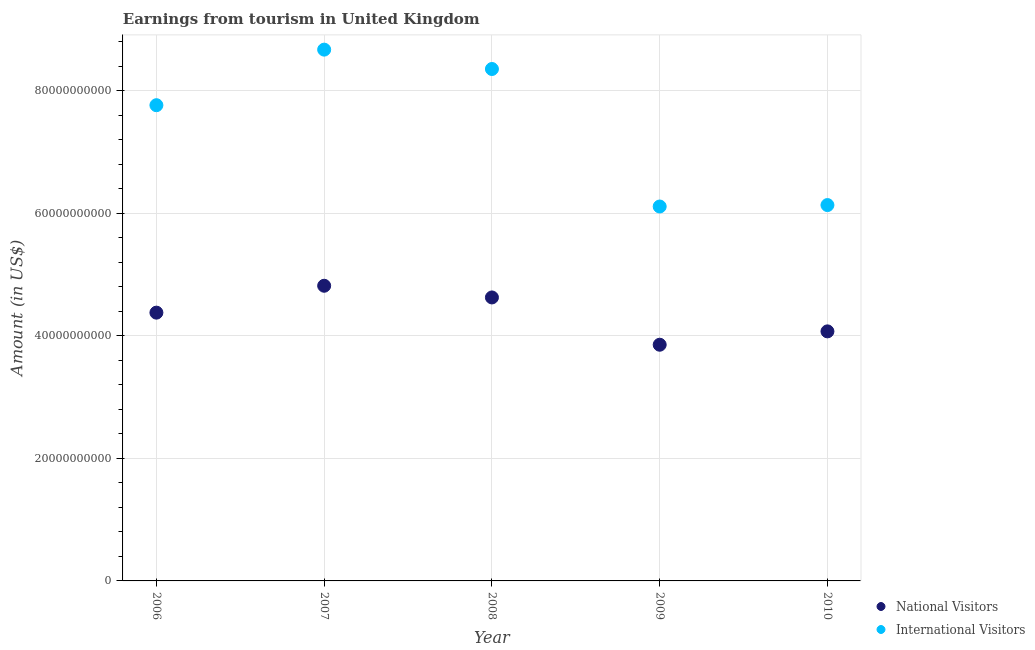How many different coloured dotlines are there?
Your response must be concise. 2. What is the amount earned from national visitors in 2008?
Provide a short and direct response. 4.63e+1. Across all years, what is the maximum amount earned from national visitors?
Give a very brief answer. 4.82e+1. Across all years, what is the minimum amount earned from national visitors?
Ensure brevity in your answer.  3.86e+1. What is the total amount earned from international visitors in the graph?
Ensure brevity in your answer.  3.71e+11. What is the difference between the amount earned from international visitors in 2006 and that in 2008?
Offer a very short reply. -5.91e+09. What is the difference between the amount earned from international visitors in 2006 and the amount earned from national visitors in 2008?
Your answer should be very brief. 3.14e+1. What is the average amount earned from national visitors per year?
Make the answer very short. 4.35e+1. In the year 2009, what is the difference between the amount earned from national visitors and amount earned from international visitors?
Make the answer very short. -2.26e+1. What is the ratio of the amount earned from national visitors in 2009 to that in 2010?
Your answer should be very brief. 0.95. Is the amount earned from national visitors in 2006 less than that in 2007?
Provide a short and direct response. Yes. Is the difference between the amount earned from national visitors in 2008 and 2010 greater than the difference between the amount earned from international visitors in 2008 and 2010?
Make the answer very short. No. What is the difference between the highest and the second highest amount earned from international visitors?
Give a very brief answer. 3.16e+09. What is the difference between the highest and the lowest amount earned from international visitors?
Provide a succinct answer. 2.56e+1. In how many years, is the amount earned from international visitors greater than the average amount earned from international visitors taken over all years?
Give a very brief answer. 3. Is the sum of the amount earned from international visitors in 2007 and 2009 greater than the maximum amount earned from national visitors across all years?
Ensure brevity in your answer.  Yes. How many dotlines are there?
Provide a succinct answer. 2. Are the values on the major ticks of Y-axis written in scientific E-notation?
Your answer should be compact. No. Does the graph contain any zero values?
Your answer should be compact. No. How many legend labels are there?
Provide a short and direct response. 2. What is the title of the graph?
Offer a very short reply. Earnings from tourism in United Kingdom. Does "Public funds" appear as one of the legend labels in the graph?
Provide a succinct answer. No. What is the label or title of the Y-axis?
Your response must be concise. Amount (in US$). What is the Amount (in US$) in National Visitors in 2006?
Give a very brief answer. 4.38e+1. What is the Amount (in US$) of International Visitors in 2006?
Offer a very short reply. 7.77e+1. What is the Amount (in US$) in National Visitors in 2007?
Your answer should be very brief. 4.82e+1. What is the Amount (in US$) in International Visitors in 2007?
Provide a short and direct response. 8.67e+1. What is the Amount (in US$) in National Visitors in 2008?
Provide a succinct answer. 4.63e+1. What is the Amount (in US$) of International Visitors in 2008?
Give a very brief answer. 8.36e+1. What is the Amount (in US$) in National Visitors in 2009?
Your response must be concise. 3.86e+1. What is the Amount (in US$) of International Visitors in 2009?
Make the answer very short. 6.11e+1. What is the Amount (in US$) of National Visitors in 2010?
Keep it short and to the point. 4.07e+1. What is the Amount (in US$) in International Visitors in 2010?
Offer a very short reply. 6.14e+1. Across all years, what is the maximum Amount (in US$) in National Visitors?
Make the answer very short. 4.82e+1. Across all years, what is the maximum Amount (in US$) in International Visitors?
Ensure brevity in your answer.  8.67e+1. Across all years, what is the minimum Amount (in US$) of National Visitors?
Provide a succinct answer. 3.86e+1. Across all years, what is the minimum Amount (in US$) in International Visitors?
Your answer should be compact. 6.11e+1. What is the total Amount (in US$) in National Visitors in the graph?
Provide a short and direct response. 2.18e+11. What is the total Amount (in US$) of International Visitors in the graph?
Keep it short and to the point. 3.71e+11. What is the difference between the Amount (in US$) of National Visitors in 2006 and that in 2007?
Keep it short and to the point. -4.39e+09. What is the difference between the Amount (in US$) in International Visitors in 2006 and that in 2007?
Your answer should be compact. -9.07e+09. What is the difference between the Amount (in US$) of National Visitors in 2006 and that in 2008?
Offer a terse response. -2.48e+09. What is the difference between the Amount (in US$) of International Visitors in 2006 and that in 2008?
Ensure brevity in your answer.  -5.91e+09. What is the difference between the Amount (in US$) of National Visitors in 2006 and that in 2009?
Offer a very short reply. 5.24e+09. What is the difference between the Amount (in US$) of International Visitors in 2006 and that in 2009?
Offer a very short reply. 1.65e+1. What is the difference between the Amount (in US$) of National Visitors in 2006 and that in 2010?
Give a very brief answer. 3.06e+09. What is the difference between the Amount (in US$) of International Visitors in 2006 and that in 2010?
Offer a very short reply. 1.63e+1. What is the difference between the Amount (in US$) of National Visitors in 2007 and that in 2008?
Provide a succinct answer. 1.91e+09. What is the difference between the Amount (in US$) in International Visitors in 2007 and that in 2008?
Make the answer very short. 3.16e+09. What is the difference between the Amount (in US$) in National Visitors in 2007 and that in 2009?
Your answer should be very brief. 9.63e+09. What is the difference between the Amount (in US$) of International Visitors in 2007 and that in 2009?
Provide a succinct answer. 2.56e+1. What is the difference between the Amount (in US$) in National Visitors in 2007 and that in 2010?
Make the answer very short. 7.45e+09. What is the difference between the Amount (in US$) in International Visitors in 2007 and that in 2010?
Offer a terse response. 2.54e+1. What is the difference between the Amount (in US$) in National Visitors in 2008 and that in 2009?
Keep it short and to the point. 7.72e+09. What is the difference between the Amount (in US$) of International Visitors in 2008 and that in 2009?
Make the answer very short. 2.25e+1. What is the difference between the Amount (in US$) in National Visitors in 2008 and that in 2010?
Provide a succinct answer. 5.54e+09. What is the difference between the Amount (in US$) in International Visitors in 2008 and that in 2010?
Make the answer very short. 2.22e+1. What is the difference between the Amount (in US$) in National Visitors in 2009 and that in 2010?
Offer a very short reply. -2.18e+09. What is the difference between the Amount (in US$) of International Visitors in 2009 and that in 2010?
Make the answer very short. -2.35e+08. What is the difference between the Amount (in US$) in National Visitors in 2006 and the Amount (in US$) in International Visitors in 2007?
Ensure brevity in your answer.  -4.29e+1. What is the difference between the Amount (in US$) of National Visitors in 2006 and the Amount (in US$) of International Visitors in 2008?
Your answer should be compact. -3.98e+1. What is the difference between the Amount (in US$) of National Visitors in 2006 and the Amount (in US$) of International Visitors in 2009?
Offer a very short reply. -1.73e+1. What is the difference between the Amount (in US$) of National Visitors in 2006 and the Amount (in US$) of International Visitors in 2010?
Ensure brevity in your answer.  -1.76e+1. What is the difference between the Amount (in US$) in National Visitors in 2007 and the Amount (in US$) in International Visitors in 2008?
Ensure brevity in your answer.  -3.54e+1. What is the difference between the Amount (in US$) in National Visitors in 2007 and the Amount (in US$) in International Visitors in 2009?
Provide a short and direct response. -1.29e+1. What is the difference between the Amount (in US$) of National Visitors in 2007 and the Amount (in US$) of International Visitors in 2010?
Your response must be concise. -1.32e+1. What is the difference between the Amount (in US$) of National Visitors in 2008 and the Amount (in US$) of International Visitors in 2009?
Provide a succinct answer. -1.48e+1. What is the difference between the Amount (in US$) in National Visitors in 2008 and the Amount (in US$) in International Visitors in 2010?
Your response must be concise. -1.51e+1. What is the difference between the Amount (in US$) in National Visitors in 2009 and the Amount (in US$) in International Visitors in 2010?
Your answer should be compact. -2.28e+1. What is the average Amount (in US$) in National Visitors per year?
Make the answer very short. 4.35e+1. What is the average Amount (in US$) in International Visitors per year?
Your response must be concise. 7.41e+1. In the year 2006, what is the difference between the Amount (in US$) of National Visitors and Amount (in US$) of International Visitors?
Provide a short and direct response. -3.39e+1. In the year 2007, what is the difference between the Amount (in US$) in National Visitors and Amount (in US$) in International Visitors?
Ensure brevity in your answer.  -3.86e+1. In the year 2008, what is the difference between the Amount (in US$) of National Visitors and Amount (in US$) of International Visitors?
Provide a succinct answer. -3.73e+1. In the year 2009, what is the difference between the Amount (in US$) of National Visitors and Amount (in US$) of International Visitors?
Ensure brevity in your answer.  -2.26e+1. In the year 2010, what is the difference between the Amount (in US$) in National Visitors and Amount (in US$) in International Visitors?
Offer a terse response. -2.06e+1. What is the ratio of the Amount (in US$) in National Visitors in 2006 to that in 2007?
Your answer should be compact. 0.91. What is the ratio of the Amount (in US$) in International Visitors in 2006 to that in 2007?
Provide a short and direct response. 0.9. What is the ratio of the Amount (in US$) of National Visitors in 2006 to that in 2008?
Provide a short and direct response. 0.95. What is the ratio of the Amount (in US$) in International Visitors in 2006 to that in 2008?
Provide a short and direct response. 0.93. What is the ratio of the Amount (in US$) in National Visitors in 2006 to that in 2009?
Keep it short and to the point. 1.14. What is the ratio of the Amount (in US$) in International Visitors in 2006 to that in 2009?
Make the answer very short. 1.27. What is the ratio of the Amount (in US$) in National Visitors in 2006 to that in 2010?
Ensure brevity in your answer.  1.07. What is the ratio of the Amount (in US$) of International Visitors in 2006 to that in 2010?
Your response must be concise. 1.27. What is the ratio of the Amount (in US$) in National Visitors in 2007 to that in 2008?
Make the answer very short. 1.04. What is the ratio of the Amount (in US$) in International Visitors in 2007 to that in 2008?
Offer a very short reply. 1.04. What is the ratio of the Amount (in US$) in National Visitors in 2007 to that in 2009?
Your answer should be compact. 1.25. What is the ratio of the Amount (in US$) of International Visitors in 2007 to that in 2009?
Your answer should be compact. 1.42. What is the ratio of the Amount (in US$) of National Visitors in 2007 to that in 2010?
Your response must be concise. 1.18. What is the ratio of the Amount (in US$) of International Visitors in 2007 to that in 2010?
Provide a short and direct response. 1.41. What is the ratio of the Amount (in US$) of National Visitors in 2008 to that in 2009?
Provide a succinct answer. 1.2. What is the ratio of the Amount (in US$) of International Visitors in 2008 to that in 2009?
Your answer should be compact. 1.37. What is the ratio of the Amount (in US$) of National Visitors in 2008 to that in 2010?
Your answer should be very brief. 1.14. What is the ratio of the Amount (in US$) of International Visitors in 2008 to that in 2010?
Offer a terse response. 1.36. What is the ratio of the Amount (in US$) in National Visitors in 2009 to that in 2010?
Your response must be concise. 0.95. What is the ratio of the Amount (in US$) of International Visitors in 2009 to that in 2010?
Provide a succinct answer. 1. What is the difference between the highest and the second highest Amount (in US$) in National Visitors?
Provide a short and direct response. 1.91e+09. What is the difference between the highest and the second highest Amount (in US$) of International Visitors?
Give a very brief answer. 3.16e+09. What is the difference between the highest and the lowest Amount (in US$) in National Visitors?
Give a very brief answer. 9.63e+09. What is the difference between the highest and the lowest Amount (in US$) of International Visitors?
Provide a short and direct response. 2.56e+1. 